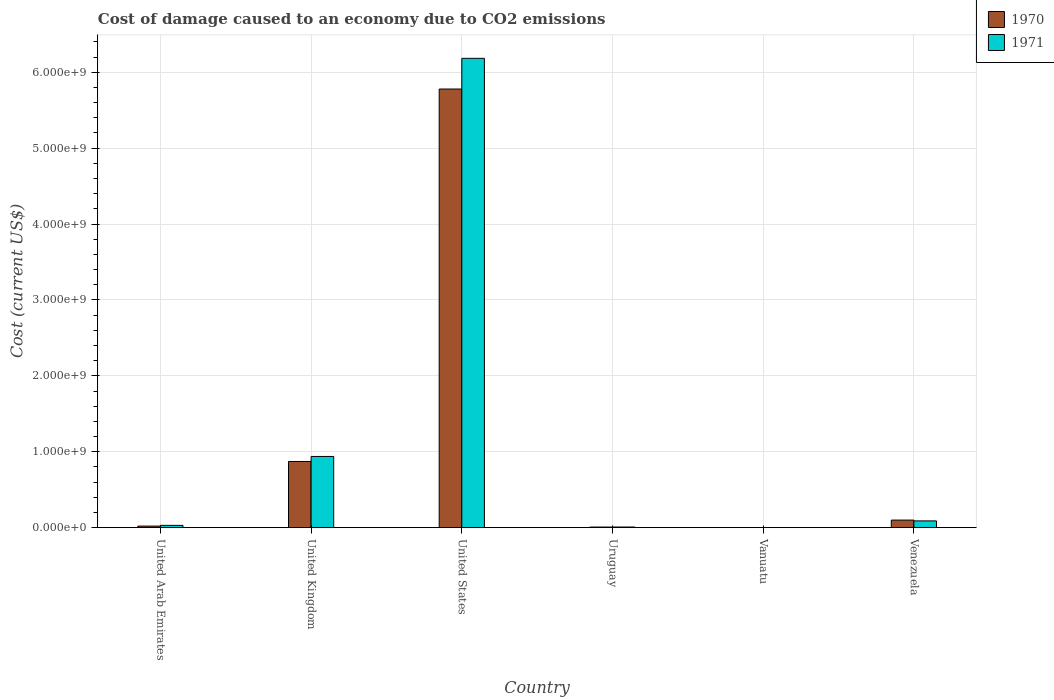How many different coloured bars are there?
Your answer should be compact. 2. How many groups of bars are there?
Ensure brevity in your answer.  6. Are the number of bars per tick equal to the number of legend labels?
Your answer should be very brief. Yes. What is the label of the 6th group of bars from the left?
Make the answer very short. Venezuela. What is the cost of damage caused due to CO2 emissisons in 1970 in Uruguay?
Give a very brief answer. 7.67e+06. Across all countries, what is the maximum cost of damage caused due to CO2 emissisons in 1970?
Ensure brevity in your answer.  5.78e+09. Across all countries, what is the minimum cost of damage caused due to CO2 emissisons in 1970?
Ensure brevity in your answer.  5.38e+04. In which country was the cost of damage caused due to CO2 emissisons in 1971 maximum?
Provide a succinct answer. United States. In which country was the cost of damage caused due to CO2 emissisons in 1971 minimum?
Provide a short and direct response. Vanuatu. What is the total cost of damage caused due to CO2 emissisons in 1971 in the graph?
Your response must be concise. 7.25e+09. What is the difference between the cost of damage caused due to CO2 emissisons in 1970 in United Arab Emirates and that in Venezuela?
Your answer should be very brief. -7.92e+07. What is the difference between the cost of damage caused due to CO2 emissisons in 1971 in United States and the cost of damage caused due to CO2 emissisons in 1970 in Uruguay?
Make the answer very short. 6.17e+09. What is the average cost of damage caused due to CO2 emissisons in 1970 per country?
Provide a short and direct response. 1.13e+09. What is the difference between the cost of damage caused due to CO2 emissisons of/in 1970 and cost of damage caused due to CO2 emissisons of/in 1971 in United Kingdom?
Your answer should be compact. -6.61e+07. In how many countries, is the cost of damage caused due to CO2 emissisons in 1970 greater than 600000000 US$?
Provide a short and direct response. 2. What is the ratio of the cost of damage caused due to CO2 emissisons in 1971 in United Kingdom to that in Uruguay?
Make the answer very short. 113.77. Is the cost of damage caused due to CO2 emissisons in 1970 in United Arab Emirates less than that in Vanuatu?
Give a very brief answer. No. What is the difference between the highest and the second highest cost of damage caused due to CO2 emissisons in 1970?
Your answer should be compact. 4.91e+09. What is the difference between the highest and the lowest cost of damage caused due to CO2 emissisons in 1970?
Your response must be concise. 5.78e+09. In how many countries, is the cost of damage caused due to CO2 emissisons in 1971 greater than the average cost of damage caused due to CO2 emissisons in 1971 taken over all countries?
Give a very brief answer. 1. Is the sum of the cost of damage caused due to CO2 emissisons in 1970 in United States and Venezuela greater than the maximum cost of damage caused due to CO2 emissisons in 1971 across all countries?
Your answer should be very brief. No. How many bars are there?
Your response must be concise. 12. Are all the bars in the graph horizontal?
Offer a terse response. No. How many countries are there in the graph?
Ensure brevity in your answer.  6. Does the graph contain any zero values?
Your answer should be compact. No. Where does the legend appear in the graph?
Keep it short and to the point. Top right. What is the title of the graph?
Your response must be concise. Cost of damage caused to an economy due to CO2 emissions. Does "1993" appear as one of the legend labels in the graph?
Keep it short and to the point. No. What is the label or title of the Y-axis?
Keep it short and to the point. Cost (current US$). What is the Cost (current US$) in 1970 in United Arab Emirates?
Offer a terse response. 2.04e+07. What is the Cost (current US$) in 1971 in United Arab Emirates?
Offer a very short reply. 3.01e+07. What is the Cost (current US$) in 1970 in United Kingdom?
Offer a very short reply. 8.72e+08. What is the Cost (current US$) in 1971 in United Kingdom?
Give a very brief answer. 9.38e+08. What is the Cost (current US$) of 1970 in United States?
Ensure brevity in your answer.  5.78e+09. What is the Cost (current US$) in 1971 in United States?
Offer a very short reply. 6.18e+09. What is the Cost (current US$) in 1970 in Uruguay?
Your answer should be compact. 7.67e+06. What is the Cost (current US$) of 1971 in Uruguay?
Provide a short and direct response. 8.24e+06. What is the Cost (current US$) of 1970 in Vanuatu?
Your response must be concise. 5.38e+04. What is the Cost (current US$) in 1971 in Vanuatu?
Your answer should be compact. 8.33e+04. What is the Cost (current US$) of 1970 in Venezuela?
Give a very brief answer. 9.95e+07. What is the Cost (current US$) of 1971 in Venezuela?
Give a very brief answer. 8.88e+07. Across all countries, what is the maximum Cost (current US$) of 1970?
Your answer should be compact. 5.78e+09. Across all countries, what is the maximum Cost (current US$) of 1971?
Your response must be concise. 6.18e+09. Across all countries, what is the minimum Cost (current US$) of 1970?
Your answer should be very brief. 5.38e+04. Across all countries, what is the minimum Cost (current US$) in 1971?
Give a very brief answer. 8.33e+04. What is the total Cost (current US$) in 1970 in the graph?
Your answer should be very brief. 6.78e+09. What is the total Cost (current US$) of 1971 in the graph?
Provide a succinct answer. 7.25e+09. What is the difference between the Cost (current US$) in 1970 in United Arab Emirates and that in United Kingdom?
Your response must be concise. -8.51e+08. What is the difference between the Cost (current US$) of 1971 in United Arab Emirates and that in United Kingdom?
Offer a terse response. -9.08e+08. What is the difference between the Cost (current US$) in 1970 in United Arab Emirates and that in United States?
Keep it short and to the point. -5.76e+09. What is the difference between the Cost (current US$) in 1971 in United Arab Emirates and that in United States?
Your answer should be compact. -6.15e+09. What is the difference between the Cost (current US$) in 1970 in United Arab Emirates and that in Uruguay?
Make the answer very short. 1.27e+07. What is the difference between the Cost (current US$) of 1971 in United Arab Emirates and that in Uruguay?
Provide a short and direct response. 2.18e+07. What is the difference between the Cost (current US$) in 1970 in United Arab Emirates and that in Vanuatu?
Provide a succinct answer. 2.03e+07. What is the difference between the Cost (current US$) of 1971 in United Arab Emirates and that in Vanuatu?
Keep it short and to the point. 3.00e+07. What is the difference between the Cost (current US$) in 1970 in United Arab Emirates and that in Venezuela?
Ensure brevity in your answer.  -7.92e+07. What is the difference between the Cost (current US$) of 1971 in United Arab Emirates and that in Venezuela?
Give a very brief answer. -5.87e+07. What is the difference between the Cost (current US$) of 1970 in United Kingdom and that in United States?
Your answer should be very brief. -4.91e+09. What is the difference between the Cost (current US$) of 1971 in United Kingdom and that in United States?
Provide a succinct answer. -5.24e+09. What is the difference between the Cost (current US$) of 1970 in United Kingdom and that in Uruguay?
Ensure brevity in your answer.  8.64e+08. What is the difference between the Cost (current US$) of 1971 in United Kingdom and that in Uruguay?
Ensure brevity in your answer.  9.30e+08. What is the difference between the Cost (current US$) in 1970 in United Kingdom and that in Vanuatu?
Make the answer very short. 8.72e+08. What is the difference between the Cost (current US$) of 1971 in United Kingdom and that in Vanuatu?
Give a very brief answer. 9.38e+08. What is the difference between the Cost (current US$) of 1970 in United Kingdom and that in Venezuela?
Provide a short and direct response. 7.72e+08. What is the difference between the Cost (current US$) of 1971 in United Kingdom and that in Venezuela?
Provide a short and direct response. 8.49e+08. What is the difference between the Cost (current US$) of 1970 in United States and that in Uruguay?
Offer a very short reply. 5.77e+09. What is the difference between the Cost (current US$) of 1971 in United States and that in Uruguay?
Provide a short and direct response. 6.17e+09. What is the difference between the Cost (current US$) in 1970 in United States and that in Vanuatu?
Provide a short and direct response. 5.78e+09. What is the difference between the Cost (current US$) of 1971 in United States and that in Vanuatu?
Your response must be concise. 6.18e+09. What is the difference between the Cost (current US$) of 1970 in United States and that in Venezuela?
Your response must be concise. 5.68e+09. What is the difference between the Cost (current US$) of 1971 in United States and that in Venezuela?
Your answer should be very brief. 6.09e+09. What is the difference between the Cost (current US$) of 1970 in Uruguay and that in Vanuatu?
Give a very brief answer. 7.61e+06. What is the difference between the Cost (current US$) of 1971 in Uruguay and that in Vanuatu?
Keep it short and to the point. 8.16e+06. What is the difference between the Cost (current US$) in 1970 in Uruguay and that in Venezuela?
Offer a terse response. -9.19e+07. What is the difference between the Cost (current US$) of 1971 in Uruguay and that in Venezuela?
Your answer should be compact. -8.05e+07. What is the difference between the Cost (current US$) in 1970 in Vanuatu and that in Venezuela?
Keep it short and to the point. -9.95e+07. What is the difference between the Cost (current US$) of 1971 in Vanuatu and that in Venezuela?
Your answer should be compact. -8.87e+07. What is the difference between the Cost (current US$) in 1970 in United Arab Emirates and the Cost (current US$) in 1971 in United Kingdom?
Offer a very short reply. -9.17e+08. What is the difference between the Cost (current US$) of 1970 in United Arab Emirates and the Cost (current US$) of 1971 in United States?
Provide a succinct answer. -6.16e+09. What is the difference between the Cost (current US$) of 1970 in United Arab Emirates and the Cost (current US$) of 1971 in Uruguay?
Offer a very short reply. 1.21e+07. What is the difference between the Cost (current US$) in 1970 in United Arab Emirates and the Cost (current US$) in 1971 in Vanuatu?
Your answer should be very brief. 2.03e+07. What is the difference between the Cost (current US$) in 1970 in United Arab Emirates and the Cost (current US$) in 1971 in Venezuela?
Ensure brevity in your answer.  -6.84e+07. What is the difference between the Cost (current US$) in 1970 in United Kingdom and the Cost (current US$) in 1971 in United States?
Keep it short and to the point. -5.31e+09. What is the difference between the Cost (current US$) of 1970 in United Kingdom and the Cost (current US$) of 1971 in Uruguay?
Your answer should be compact. 8.63e+08. What is the difference between the Cost (current US$) of 1970 in United Kingdom and the Cost (current US$) of 1971 in Vanuatu?
Ensure brevity in your answer.  8.72e+08. What is the difference between the Cost (current US$) in 1970 in United Kingdom and the Cost (current US$) in 1971 in Venezuela?
Your response must be concise. 7.83e+08. What is the difference between the Cost (current US$) of 1970 in United States and the Cost (current US$) of 1971 in Uruguay?
Your answer should be very brief. 5.77e+09. What is the difference between the Cost (current US$) of 1970 in United States and the Cost (current US$) of 1971 in Vanuatu?
Ensure brevity in your answer.  5.78e+09. What is the difference between the Cost (current US$) of 1970 in United States and the Cost (current US$) of 1971 in Venezuela?
Offer a terse response. 5.69e+09. What is the difference between the Cost (current US$) in 1970 in Uruguay and the Cost (current US$) in 1971 in Vanuatu?
Make the answer very short. 7.58e+06. What is the difference between the Cost (current US$) in 1970 in Uruguay and the Cost (current US$) in 1971 in Venezuela?
Keep it short and to the point. -8.11e+07. What is the difference between the Cost (current US$) in 1970 in Vanuatu and the Cost (current US$) in 1971 in Venezuela?
Ensure brevity in your answer.  -8.87e+07. What is the average Cost (current US$) of 1970 per country?
Your response must be concise. 1.13e+09. What is the average Cost (current US$) of 1971 per country?
Provide a short and direct response. 1.21e+09. What is the difference between the Cost (current US$) of 1970 and Cost (current US$) of 1971 in United Arab Emirates?
Give a very brief answer. -9.71e+06. What is the difference between the Cost (current US$) in 1970 and Cost (current US$) in 1971 in United Kingdom?
Give a very brief answer. -6.61e+07. What is the difference between the Cost (current US$) in 1970 and Cost (current US$) in 1971 in United States?
Make the answer very short. -4.04e+08. What is the difference between the Cost (current US$) in 1970 and Cost (current US$) in 1971 in Uruguay?
Ensure brevity in your answer.  -5.78e+05. What is the difference between the Cost (current US$) in 1970 and Cost (current US$) in 1971 in Vanuatu?
Make the answer very short. -2.94e+04. What is the difference between the Cost (current US$) of 1970 and Cost (current US$) of 1971 in Venezuela?
Your response must be concise. 1.07e+07. What is the ratio of the Cost (current US$) in 1970 in United Arab Emirates to that in United Kingdom?
Your answer should be very brief. 0.02. What is the ratio of the Cost (current US$) of 1971 in United Arab Emirates to that in United Kingdom?
Your answer should be very brief. 0.03. What is the ratio of the Cost (current US$) of 1970 in United Arab Emirates to that in United States?
Offer a very short reply. 0. What is the ratio of the Cost (current US$) of 1971 in United Arab Emirates to that in United States?
Offer a terse response. 0. What is the ratio of the Cost (current US$) of 1970 in United Arab Emirates to that in Uruguay?
Give a very brief answer. 2.66. What is the ratio of the Cost (current US$) of 1971 in United Arab Emirates to that in Uruguay?
Your answer should be compact. 3.65. What is the ratio of the Cost (current US$) in 1970 in United Arab Emirates to that in Vanuatu?
Provide a succinct answer. 378. What is the ratio of the Cost (current US$) in 1971 in United Arab Emirates to that in Vanuatu?
Offer a terse response. 361.06. What is the ratio of the Cost (current US$) of 1970 in United Arab Emirates to that in Venezuela?
Offer a very short reply. 0.2. What is the ratio of the Cost (current US$) of 1971 in United Arab Emirates to that in Venezuela?
Make the answer very short. 0.34. What is the ratio of the Cost (current US$) of 1970 in United Kingdom to that in United States?
Give a very brief answer. 0.15. What is the ratio of the Cost (current US$) of 1971 in United Kingdom to that in United States?
Provide a short and direct response. 0.15. What is the ratio of the Cost (current US$) of 1970 in United Kingdom to that in Uruguay?
Provide a short and direct response. 113.72. What is the ratio of the Cost (current US$) in 1971 in United Kingdom to that in Uruguay?
Provide a short and direct response. 113.77. What is the ratio of the Cost (current US$) in 1970 in United Kingdom to that in Vanuatu?
Your answer should be very brief. 1.62e+04. What is the ratio of the Cost (current US$) in 1971 in United Kingdom to that in Vanuatu?
Keep it short and to the point. 1.13e+04. What is the ratio of the Cost (current US$) in 1970 in United Kingdom to that in Venezuela?
Offer a very short reply. 8.76. What is the ratio of the Cost (current US$) in 1971 in United Kingdom to that in Venezuela?
Your response must be concise. 10.56. What is the ratio of the Cost (current US$) of 1970 in United States to that in Uruguay?
Ensure brevity in your answer.  753.83. What is the ratio of the Cost (current US$) in 1971 in United States to that in Uruguay?
Provide a succinct answer. 750.06. What is the ratio of the Cost (current US$) in 1970 in United States to that in Vanuatu?
Provide a short and direct response. 1.07e+05. What is the ratio of the Cost (current US$) in 1971 in United States to that in Vanuatu?
Provide a succinct answer. 7.43e+04. What is the ratio of the Cost (current US$) in 1970 in United States to that in Venezuela?
Provide a short and direct response. 58.06. What is the ratio of the Cost (current US$) of 1971 in United States to that in Venezuela?
Your answer should be compact. 69.64. What is the ratio of the Cost (current US$) of 1970 in Uruguay to that in Vanuatu?
Keep it short and to the point. 142.36. What is the ratio of the Cost (current US$) of 1970 in Uruguay to that in Venezuela?
Your response must be concise. 0.08. What is the ratio of the Cost (current US$) in 1971 in Uruguay to that in Venezuela?
Give a very brief answer. 0.09. What is the ratio of the Cost (current US$) of 1970 in Vanuatu to that in Venezuela?
Offer a terse response. 0. What is the ratio of the Cost (current US$) of 1971 in Vanuatu to that in Venezuela?
Make the answer very short. 0. What is the difference between the highest and the second highest Cost (current US$) in 1970?
Your answer should be compact. 4.91e+09. What is the difference between the highest and the second highest Cost (current US$) in 1971?
Your response must be concise. 5.24e+09. What is the difference between the highest and the lowest Cost (current US$) in 1970?
Your answer should be compact. 5.78e+09. What is the difference between the highest and the lowest Cost (current US$) in 1971?
Your response must be concise. 6.18e+09. 